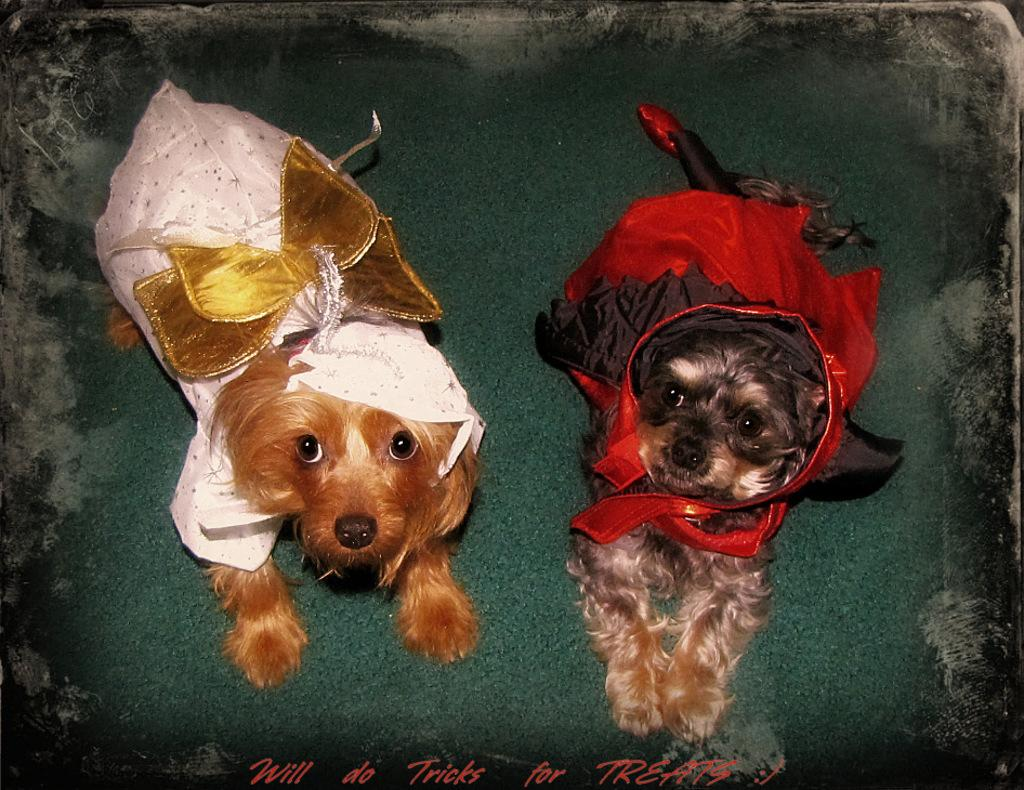How many dogs are present in the image? There are two dogs in the image. What are the dogs wearing? The dogs are wearing dresses. Where are the dogs located in the image? The dogs are laying on a path. Can you describe any additional features of the image? There is a watermark on the image. What type of sheet is covering the dogs in the image? There is no sheet covering the dogs in the image; they are wearing dresses. How many dogs are biting each other in the image? There are no dogs biting each other in the image; the dogs are laying on a path and wearing dresses. 